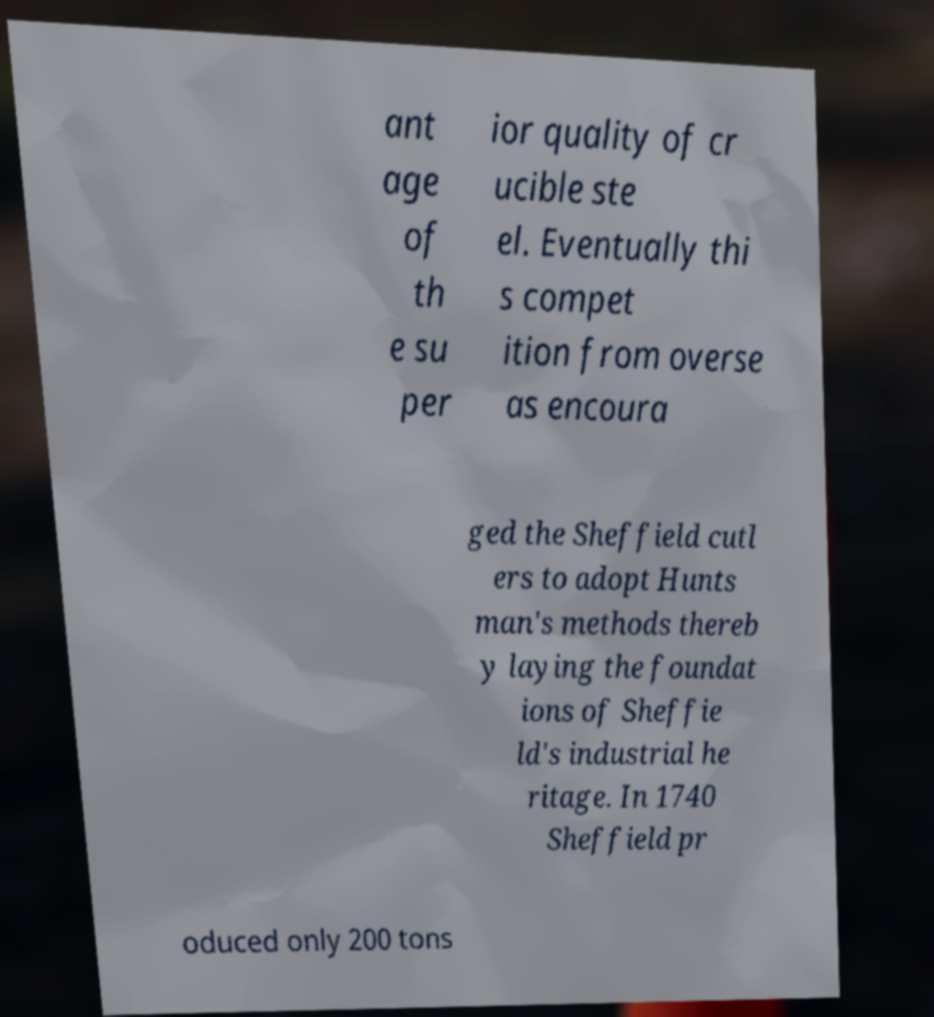I need the written content from this picture converted into text. Can you do that? ant age of th e su per ior quality of cr ucible ste el. Eventually thi s compet ition from overse as encoura ged the Sheffield cutl ers to adopt Hunts man's methods thereb y laying the foundat ions of Sheffie ld's industrial he ritage. In 1740 Sheffield pr oduced only 200 tons 